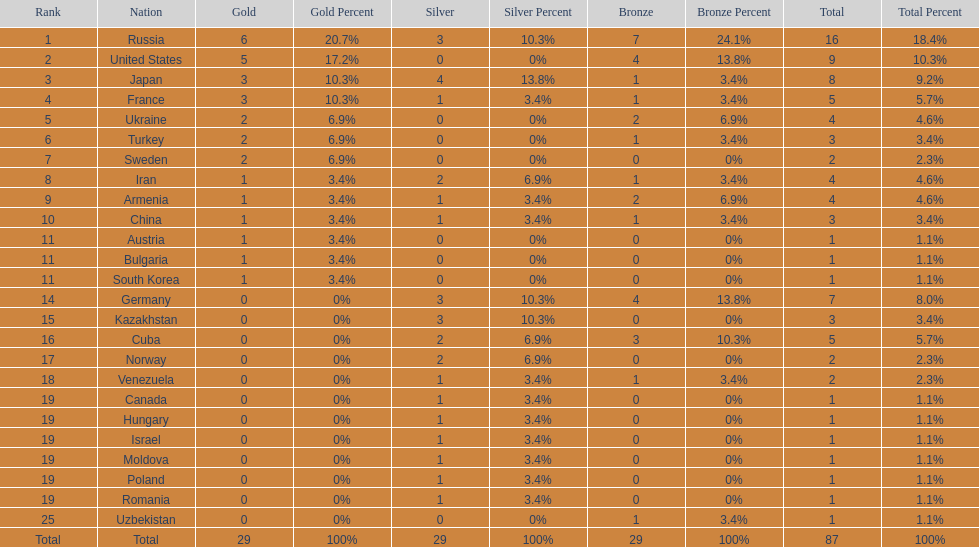Which country had the highest number of medals? Russia. 